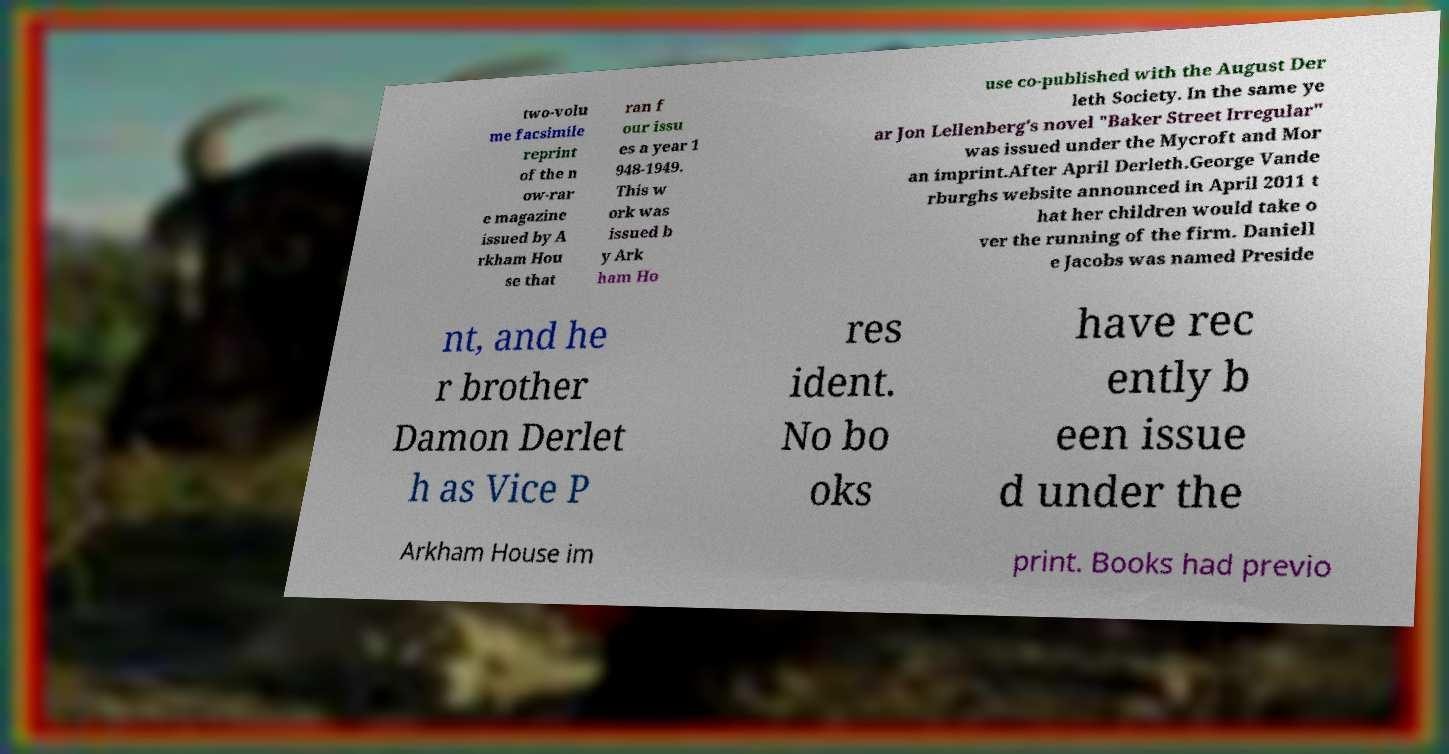Could you extract and type out the text from this image? two-volu me facsimile reprint of the n ow-rar e magazine issued by A rkham Hou se that ran f our issu es a year 1 948-1949. This w ork was issued b y Ark ham Ho use co-published with the August Der leth Society. In the same ye ar Jon Lellenberg's novel "Baker Street Irregular" was issued under the Mycroft and Mor an imprint.After April Derleth.George Vande rburghs website announced in April 2011 t hat her children would take o ver the running of the firm. Daniell e Jacobs was named Preside nt, and he r brother Damon Derlet h as Vice P res ident. No bo oks have rec ently b een issue d under the Arkham House im print. Books had previo 